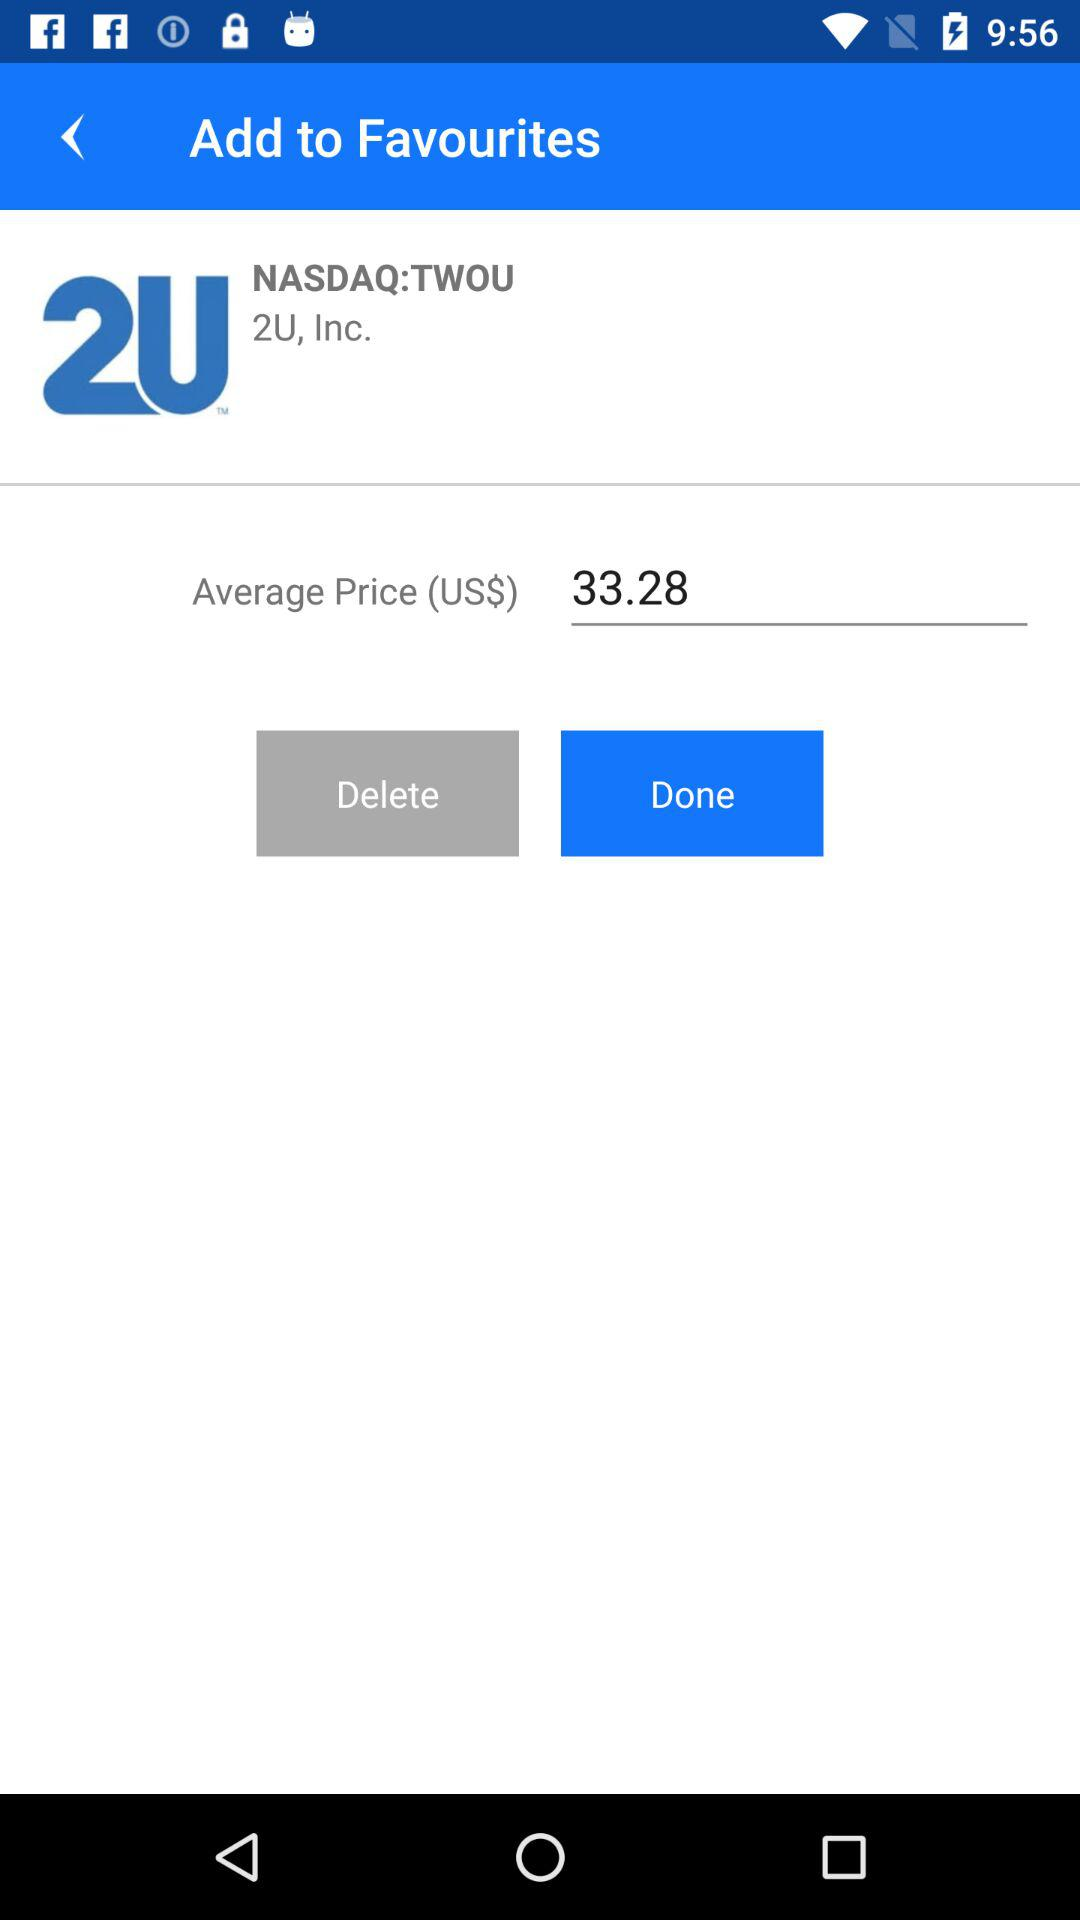How much is the average price of 2U stock?
Answer the question using a single word or phrase. 33.28 